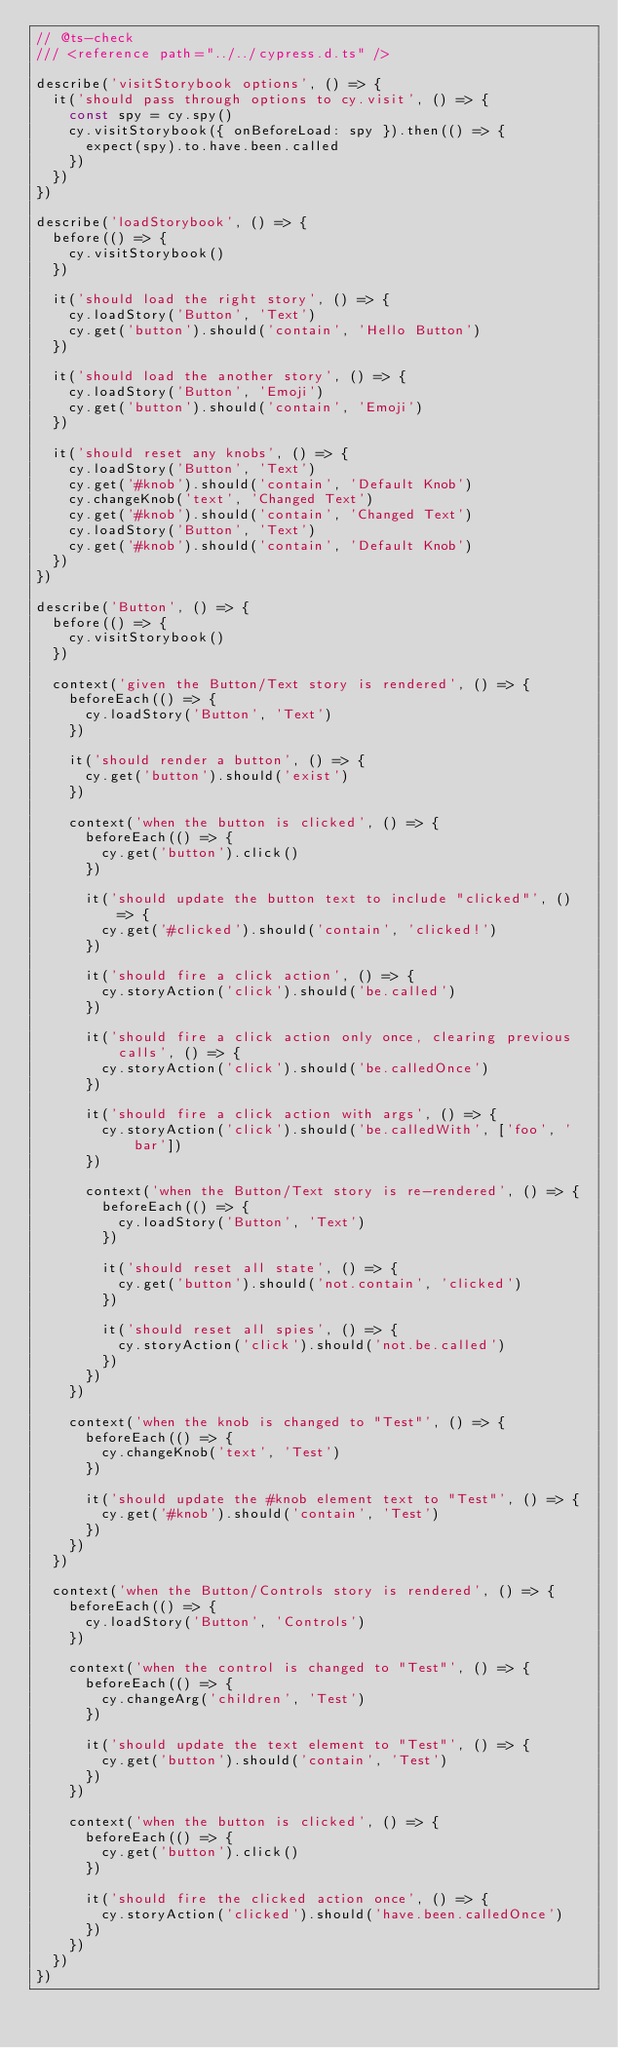Convert code to text. <code><loc_0><loc_0><loc_500><loc_500><_JavaScript_>// @ts-check
/// <reference path="../../cypress.d.ts" />

describe('visitStorybook options', () => {
  it('should pass through options to cy.visit', () => {
    const spy = cy.spy()
    cy.visitStorybook({ onBeforeLoad: spy }).then(() => {
      expect(spy).to.have.been.called
    })
  })
})

describe('loadStorybook', () => {
  before(() => {
    cy.visitStorybook()
  })

  it('should load the right story', () => {
    cy.loadStory('Button', 'Text')
    cy.get('button').should('contain', 'Hello Button')
  })

  it('should load the another story', () => {
    cy.loadStory('Button', 'Emoji')
    cy.get('button').should('contain', 'Emoji')
  })

  it('should reset any knobs', () => {
    cy.loadStory('Button', 'Text')
    cy.get('#knob').should('contain', 'Default Knob')
    cy.changeKnob('text', 'Changed Text')
    cy.get('#knob').should('contain', 'Changed Text')
    cy.loadStory('Button', 'Text')
    cy.get('#knob').should('contain', 'Default Knob')
  })
})

describe('Button', () => {
  before(() => {
    cy.visitStorybook()
  })

  context('given the Button/Text story is rendered', () => {
    beforeEach(() => {
      cy.loadStory('Button', 'Text')
    })

    it('should render a button', () => {
      cy.get('button').should('exist')
    })

    context('when the button is clicked', () => {
      beforeEach(() => {
        cy.get('button').click()
      })

      it('should update the button text to include "clicked"', () => {
        cy.get('#clicked').should('contain', 'clicked!')
      })

      it('should fire a click action', () => {
        cy.storyAction('click').should('be.called')
      })

      it('should fire a click action only once, clearing previous calls', () => {
        cy.storyAction('click').should('be.calledOnce')
      })

      it('should fire a click action with args', () => {
        cy.storyAction('click').should('be.calledWith', ['foo', 'bar'])
      })

      context('when the Button/Text story is re-rendered', () => {
        beforeEach(() => {
          cy.loadStory('Button', 'Text')
        })

        it('should reset all state', () => {
          cy.get('button').should('not.contain', 'clicked')
        })

        it('should reset all spies', () => {
          cy.storyAction('click').should('not.be.called')
        })
      })
    })

    context('when the knob is changed to "Test"', () => {
      beforeEach(() => {
        cy.changeKnob('text', 'Test')
      })

      it('should update the #knob element text to "Test"', () => {
        cy.get('#knob').should('contain', 'Test')
      })
    })
  })

  context('when the Button/Controls story is rendered', () => {
    beforeEach(() => {
      cy.loadStory('Button', 'Controls')
    })

    context('when the control is changed to "Test"', () => {
      beforeEach(() => {
        cy.changeArg('children', 'Test')
      })

      it('should update the text element to "Test"', () => {
        cy.get('button').should('contain', 'Test')
      })
    })

    context('when the button is clicked', () => {
      beforeEach(() => {
        cy.get('button').click()
      })

      it('should fire the clicked action once', () => {
        cy.storyAction('clicked').should('have.been.calledOnce')
      })
    })
  })
})
</code> 